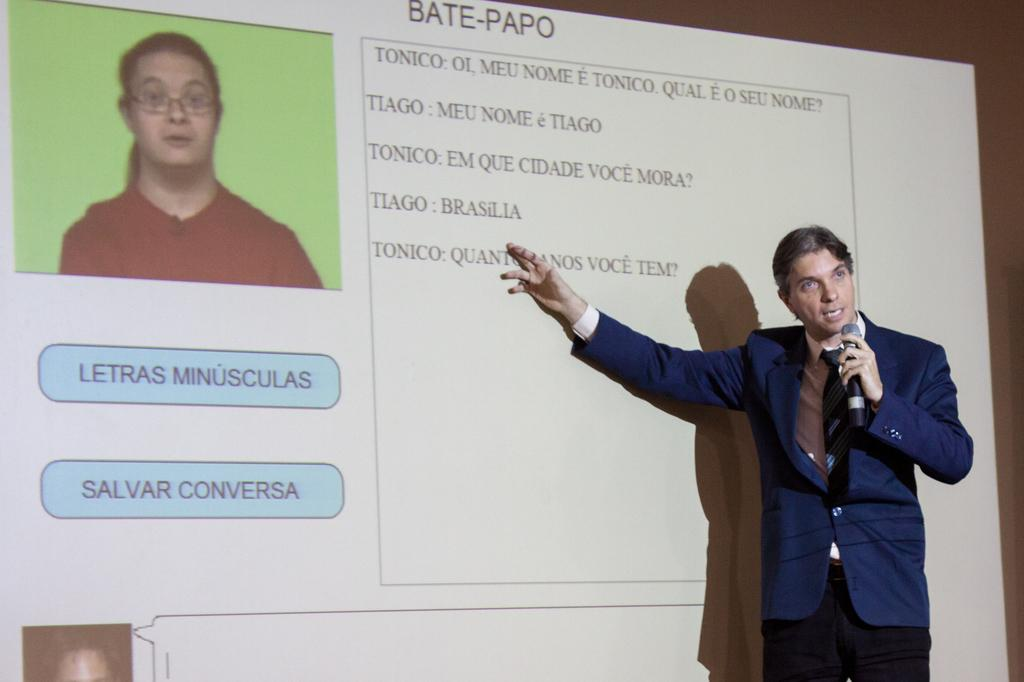What is the main subject of the image? There is a person in the image. What is the person holding in the image? The person is holding a microphone. What can be seen beside the person in the image? There is a screen beside the person. What is displayed on the screen? The screen displays a picture and text. What activity are the ducks participating in on the screen? There are no ducks present in the image, and therefore no such activity can be observed. 